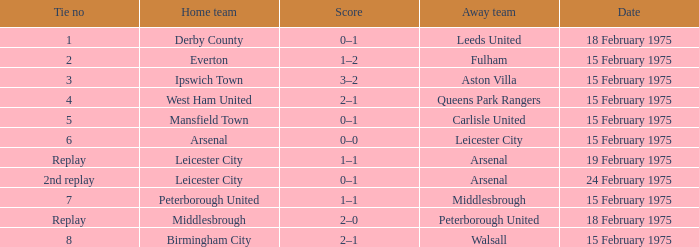What was the date when the away team was the leeds united? 18 February 1975. 